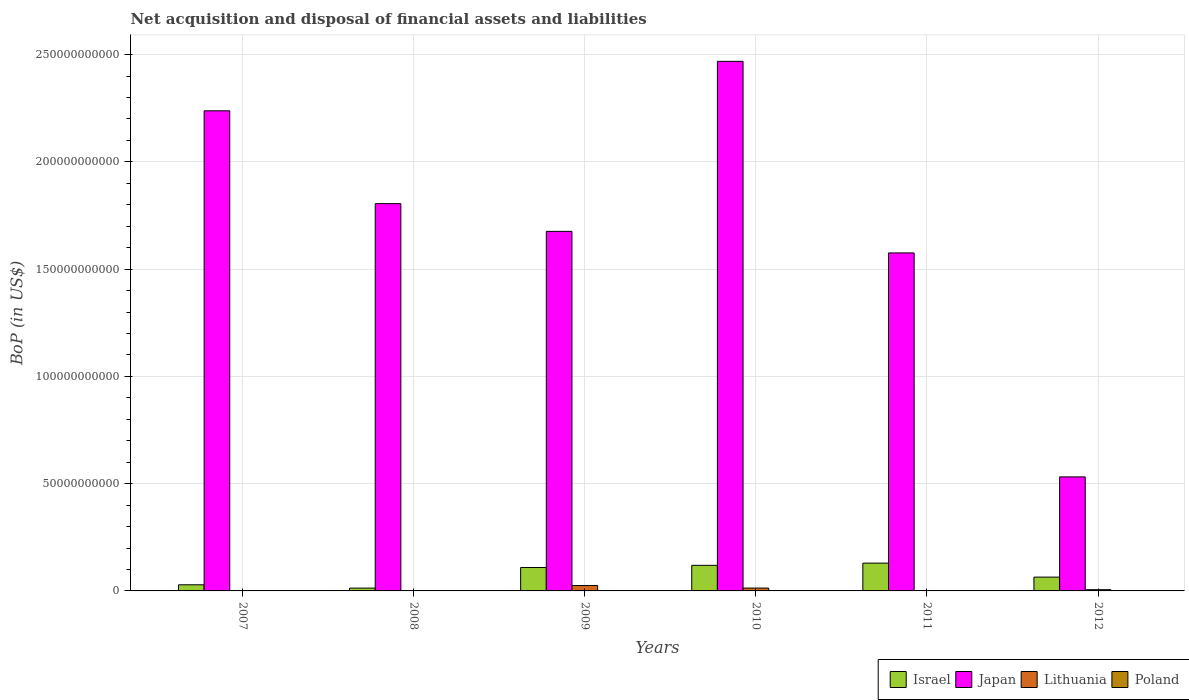How many bars are there on the 2nd tick from the left?
Offer a terse response. 2. How many bars are there on the 6th tick from the right?
Offer a very short reply. 2. What is the Balance of Payments in Japan in 2008?
Give a very brief answer. 1.81e+11. Across all years, what is the maximum Balance of Payments in Japan?
Make the answer very short. 2.47e+11. Across all years, what is the minimum Balance of Payments in Japan?
Make the answer very short. 5.32e+1. What is the total Balance of Payments in Israel in the graph?
Make the answer very short. 4.64e+1. What is the difference between the Balance of Payments in Israel in 2007 and that in 2011?
Your answer should be compact. -1.01e+1. What is the difference between the Balance of Payments in Japan in 2007 and the Balance of Payments in Poland in 2012?
Give a very brief answer. 2.24e+11. What is the average Balance of Payments in Israel per year?
Provide a succinct answer. 7.74e+09. In the year 2008, what is the difference between the Balance of Payments in Japan and Balance of Payments in Israel?
Your answer should be very brief. 1.79e+11. What is the ratio of the Balance of Payments in Israel in 2010 to that in 2012?
Provide a succinct answer. 1.85. What is the difference between the highest and the second highest Balance of Payments in Lithuania?
Your response must be concise. 1.18e+09. What is the difference between the highest and the lowest Balance of Payments in Lithuania?
Make the answer very short. 2.51e+09. In how many years, is the Balance of Payments in Japan greater than the average Balance of Payments in Japan taken over all years?
Give a very brief answer. 3. Is the sum of the Balance of Payments in Israel in 2008 and 2010 greater than the maximum Balance of Payments in Poland across all years?
Keep it short and to the point. Yes. Is it the case that in every year, the sum of the Balance of Payments in Japan and Balance of Payments in Poland is greater than the Balance of Payments in Israel?
Keep it short and to the point. Yes. How many bars are there?
Offer a terse response. 15. What is the difference between two consecutive major ticks on the Y-axis?
Your answer should be compact. 5.00e+1. Are the values on the major ticks of Y-axis written in scientific E-notation?
Offer a terse response. No. Where does the legend appear in the graph?
Your answer should be very brief. Bottom right. How are the legend labels stacked?
Keep it short and to the point. Horizontal. What is the title of the graph?
Provide a short and direct response. Net acquisition and disposal of financial assets and liabilities. What is the label or title of the Y-axis?
Make the answer very short. BoP (in US$). What is the BoP (in US$) of Israel in 2007?
Make the answer very short. 2.86e+09. What is the BoP (in US$) in Japan in 2007?
Provide a short and direct response. 2.24e+11. What is the BoP (in US$) in Lithuania in 2007?
Your response must be concise. 0. What is the BoP (in US$) in Israel in 2008?
Ensure brevity in your answer.  1.32e+09. What is the BoP (in US$) of Japan in 2008?
Keep it short and to the point. 1.81e+11. What is the BoP (in US$) in Lithuania in 2008?
Give a very brief answer. 0. What is the BoP (in US$) of Israel in 2009?
Offer a terse response. 1.09e+1. What is the BoP (in US$) in Japan in 2009?
Provide a short and direct response. 1.68e+11. What is the BoP (in US$) in Lithuania in 2009?
Give a very brief answer. 2.51e+09. What is the BoP (in US$) of Israel in 2010?
Provide a succinct answer. 1.19e+1. What is the BoP (in US$) of Japan in 2010?
Make the answer very short. 2.47e+11. What is the BoP (in US$) of Lithuania in 2010?
Provide a short and direct response. 1.34e+09. What is the BoP (in US$) in Poland in 2010?
Provide a succinct answer. 0. What is the BoP (in US$) in Israel in 2011?
Your answer should be very brief. 1.30e+1. What is the BoP (in US$) of Japan in 2011?
Make the answer very short. 1.58e+11. What is the BoP (in US$) of Israel in 2012?
Offer a terse response. 6.43e+09. What is the BoP (in US$) of Japan in 2012?
Provide a succinct answer. 5.32e+1. What is the BoP (in US$) of Lithuania in 2012?
Your response must be concise. 5.72e+08. Across all years, what is the maximum BoP (in US$) in Israel?
Keep it short and to the point. 1.30e+1. Across all years, what is the maximum BoP (in US$) in Japan?
Offer a terse response. 2.47e+11. Across all years, what is the maximum BoP (in US$) in Lithuania?
Provide a short and direct response. 2.51e+09. Across all years, what is the minimum BoP (in US$) of Israel?
Keep it short and to the point. 1.32e+09. Across all years, what is the minimum BoP (in US$) in Japan?
Give a very brief answer. 5.32e+1. What is the total BoP (in US$) in Israel in the graph?
Keep it short and to the point. 4.64e+1. What is the total BoP (in US$) of Japan in the graph?
Make the answer very short. 1.03e+12. What is the total BoP (in US$) in Lithuania in the graph?
Make the answer very short. 4.42e+09. What is the total BoP (in US$) of Poland in the graph?
Ensure brevity in your answer.  0. What is the difference between the BoP (in US$) of Israel in 2007 and that in 2008?
Provide a short and direct response. 1.54e+09. What is the difference between the BoP (in US$) in Japan in 2007 and that in 2008?
Keep it short and to the point. 4.33e+1. What is the difference between the BoP (in US$) in Israel in 2007 and that in 2009?
Provide a succinct answer. -8.06e+09. What is the difference between the BoP (in US$) in Japan in 2007 and that in 2009?
Your response must be concise. 5.62e+1. What is the difference between the BoP (in US$) of Israel in 2007 and that in 2010?
Your response must be concise. -9.07e+09. What is the difference between the BoP (in US$) of Japan in 2007 and that in 2010?
Give a very brief answer. -2.31e+1. What is the difference between the BoP (in US$) in Israel in 2007 and that in 2011?
Keep it short and to the point. -1.01e+1. What is the difference between the BoP (in US$) in Japan in 2007 and that in 2011?
Ensure brevity in your answer.  6.63e+1. What is the difference between the BoP (in US$) in Israel in 2007 and that in 2012?
Offer a very short reply. -3.57e+09. What is the difference between the BoP (in US$) in Japan in 2007 and that in 2012?
Offer a terse response. 1.71e+11. What is the difference between the BoP (in US$) in Israel in 2008 and that in 2009?
Your answer should be very brief. -9.60e+09. What is the difference between the BoP (in US$) in Japan in 2008 and that in 2009?
Ensure brevity in your answer.  1.29e+1. What is the difference between the BoP (in US$) in Israel in 2008 and that in 2010?
Your answer should be very brief. -1.06e+1. What is the difference between the BoP (in US$) in Japan in 2008 and that in 2010?
Give a very brief answer. -6.63e+1. What is the difference between the BoP (in US$) in Israel in 2008 and that in 2011?
Give a very brief answer. -1.16e+1. What is the difference between the BoP (in US$) of Japan in 2008 and that in 2011?
Provide a succinct answer. 2.30e+1. What is the difference between the BoP (in US$) of Israel in 2008 and that in 2012?
Your response must be concise. -5.12e+09. What is the difference between the BoP (in US$) in Japan in 2008 and that in 2012?
Offer a very short reply. 1.27e+11. What is the difference between the BoP (in US$) of Israel in 2009 and that in 2010?
Your answer should be compact. -1.01e+09. What is the difference between the BoP (in US$) in Japan in 2009 and that in 2010?
Keep it short and to the point. -7.93e+1. What is the difference between the BoP (in US$) of Lithuania in 2009 and that in 2010?
Offer a very short reply. 1.18e+09. What is the difference between the BoP (in US$) of Israel in 2009 and that in 2011?
Your answer should be very brief. -2.04e+09. What is the difference between the BoP (in US$) in Japan in 2009 and that in 2011?
Your response must be concise. 1.01e+1. What is the difference between the BoP (in US$) in Israel in 2009 and that in 2012?
Provide a succinct answer. 4.48e+09. What is the difference between the BoP (in US$) of Japan in 2009 and that in 2012?
Your answer should be very brief. 1.14e+11. What is the difference between the BoP (in US$) in Lithuania in 2009 and that in 2012?
Your response must be concise. 1.94e+09. What is the difference between the BoP (in US$) in Israel in 2010 and that in 2011?
Ensure brevity in your answer.  -1.04e+09. What is the difference between the BoP (in US$) of Japan in 2010 and that in 2011?
Keep it short and to the point. 8.93e+1. What is the difference between the BoP (in US$) in Israel in 2010 and that in 2012?
Provide a succinct answer. 5.49e+09. What is the difference between the BoP (in US$) in Japan in 2010 and that in 2012?
Your answer should be compact. 1.94e+11. What is the difference between the BoP (in US$) in Lithuania in 2010 and that in 2012?
Your response must be concise. 7.67e+08. What is the difference between the BoP (in US$) in Israel in 2011 and that in 2012?
Your response must be concise. 6.53e+09. What is the difference between the BoP (in US$) in Japan in 2011 and that in 2012?
Your response must be concise. 1.04e+11. What is the difference between the BoP (in US$) of Israel in 2007 and the BoP (in US$) of Japan in 2008?
Your response must be concise. -1.78e+11. What is the difference between the BoP (in US$) in Israel in 2007 and the BoP (in US$) in Japan in 2009?
Give a very brief answer. -1.65e+11. What is the difference between the BoP (in US$) in Israel in 2007 and the BoP (in US$) in Lithuania in 2009?
Keep it short and to the point. 3.48e+08. What is the difference between the BoP (in US$) in Japan in 2007 and the BoP (in US$) in Lithuania in 2009?
Your response must be concise. 2.21e+11. What is the difference between the BoP (in US$) in Israel in 2007 and the BoP (in US$) in Japan in 2010?
Give a very brief answer. -2.44e+11. What is the difference between the BoP (in US$) in Israel in 2007 and the BoP (in US$) in Lithuania in 2010?
Your answer should be very brief. 1.52e+09. What is the difference between the BoP (in US$) in Japan in 2007 and the BoP (in US$) in Lithuania in 2010?
Your answer should be very brief. 2.22e+11. What is the difference between the BoP (in US$) of Israel in 2007 and the BoP (in US$) of Japan in 2011?
Your answer should be compact. -1.55e+11. What is the difference between the BoP (in US$) in Israel in 2007 and the BoP (in US$) in Japan in 2012?
Ensure brevity in your answer.  -5.03e+1. What is the difference between the BoP (in US$) of Israel in 2007 and the BoP (in US$) of Lithuania in 2012?
Offer a very short reply. 2.29e+09. What is the difference between the BoP (in US$) in Japan in 2007 and the BoP (in US$) in Lithuania in 2012?
Give a very brief answer. 2.23e+11. What is the difference between the BoP (in US$) in Israel in 2008 and the BoP (in US$) in Japan in 2009?
Make the answer very short. -1.66e+11. What is the difference between the BoP (in US$) in Israel in 2008 and the BoP (in US$) in Lithuania in 2009?
Make the answer very short. -1.20e+09. What is the difference between the BoP (in US$) of Japan in 2008 and the BoP (in US$) of Lithuania in 2009?
Give a very brief answer. 1.78e+11. What is the difference between the BoP (in US$) of Israel in 2008 and the BoP (in US$) of Japan in 2010?
Make the answer very short. -2.46e+11. What is the difference between the BoP (in US$) in Israel in 2008 and the BoP (in US$) in Lithuania in 2010?
Offer a very short reply. -2.12e+07. What is the difference between the BoP (in US$) in Japan in 2008 and the BoP (in US$) in Lithuania in 2010?
Your response must be concise. 1.79e+11. What is the difference between the BoP (in US$) of Israel in 2008 and the BoP (in US$) of Japan in 2011?
Ensure brevity in your answer.  -1.56e+11. What is the difference between the BoP (in US$) of Israel in 2008 and the BoP (in US$) of Japan in 2012?
Ensure brevity in your answer.  -5.18e+1. What is the difference between the BoP (in US$) in Israel in 2008 and the BoP (in US$) in Lithuania in 2012?
Offer a terse response. 7.46e+08. What is the difference between the BoP (in US$) of Japan in 2008 and the BoP (in US$) of Lithuania in 2012?
Keep it short and to the point. 1.80e+11. What is the difference between the BoP (in US$) of Israel in 2009 and the BoP (in US$) of Japan in 2010?
Provide a short and direct response. -2.36e+11. What is the difference between the BoP (in US$) of Israel in 2009 and the BoP (in US$) of Lithuania in 2010?
Your answer should be compact. 9.58e+09. What is the difference between the BoP (in US$) in Japan in 2009 and the BoP (in US$) in Lithuania in 2010?
Give a very brief answer. 1.66e+11. What is the difference between the BoP (in US$) in Israel in 2009 and the BoP (in US$) in Japan in 2011?
Your answer should be very brief. -1.47e+11. What is the difference between the BoP (in US$) in Israel in 2009 and the BoP (in US$) in Japan in 2012?
Your answer should be very brief. -4.22e+1. What is the difference between the BoP (in US$) of Israel in 2009 and the BoP (in US$) of Lithuania in 2012?
Give a very brief answer. 1.03e+1. What is the difference between the BoP (in US$) in Japan in 2009 and the BoP (in US$) in Lithuania in 2012?
Keep it short and to the point. 1.67e+11. What is the difference between the BoP (in US$) of Israel in 2010 and the BoP (in US$) of Japan in 2011?
Give a very brief answer. -1.46e+11. What is the difference between the BoP (in US$) in Israel in 2010 and the BoP (in US$) in Japan in 2012?
Ensure brevity in your answer.  -4.12e+1. What is the difference between the BoP (in US$) of Israel in 2010 and the BoP (in US$) of Lithuania in 2012?
Provide a short and direct response. 1.14e+1. What is the difference between the BoP (in US$) of Japan in 2010 and the BoP (in US$) of Lithuania in 2012?
Your response must be concise. 2.46e+11. What is the difference between the BoP (in US$) of Israel in 2011 and the BoP (in US$) of Japan in 2012?
Your response must be concise. -4.02e+1. What is the difference between the BoP (in US$) in Israel in 2011 and the BoP (in US$) in Lithuania in 2012?
Keep it short and to the point. 1.24e+1. What is the difference between the BoP (in US$) of Japan in 2011 and the BoP (in US$) of Lithuania in 2012?
Offer a very short reply. 1.57e+11. What is the average BoP (in US$) of Israel per year?
Keep it short and to the point. 7.74e+09. What is the average BoP (in US$) in Japan per year?
Your response must be concise. 1.72e+11. What is the average BoP (in US$) in Lithuania per year?
Give a very brief answer. 7.37e+08. What is the average BoP (in US$) of Poland per year?
Ensure brevity in your answer.  0. In the year 2007, what is the difference between the BoP (in US$) of Israel and BoP (in US$) of Japan?
Your answer should be very brief. -2.21e+11. In the year 2008, what is the difference between the BoP (in US$) in Israel and BoP (in US$) in Japan?
Keep it short and to the point. -1.79e+11. In the year 2009, what is the difference between the BoP (in US$) in Israel and BoP (in US$) in Japan?
Ensure brevity in your answer.  -1.57e+11. In the year 2009, what is the difference between the BoP (in US$) of Israel and BoP (in US$) of Lithuania?
Your response must be concise. 8.40e+09. In the year 2009, what is the difference between the BoP (in US$) in Japan and BoP (in US$) in Lithuania?
Give a very brief answer. 1.65e+11. In the year 2010, what is the difference between the BoP (in US$) in Israel and BoP (in US$) in Japan?
Your answer should be very brief. -2.35e+11. In the year 2010, what is the difference between the BoP (in US$) of Israel and BoP (in US$) of Lithuania?
Your response must be concise. 1.06e+1. In the year 2010, what is the difference between the BoP (in US$) of Japan and BoP (in US$) of Lithuania?
Your response must be concise. 2.46e+11. In the year 2011, what is the difference between the BoP (in US$) in Israel and BoP (in US$) in Japan?
Ensure brevity in your answer.  -1.45e+11. In the year 2012, what is the difference between the BoP (in US$) of Israel and BoP (in US$) of Japan?
Offer a very short reply. -4.67e+1. In the year 2012, what is the difference between the BoP (in US$) in Israel and BoP (in US$) in Lithuania?
Keep it short and to the point. 5.86e+09. In the year 2012, what is the difference between the BoP (in US$) in Japan and BoP (in US$) in Lithuania?
Provide a short and direct response. 5.26e+1. What is the ratio of the BoP (in US$) of Israel in 2007 to that in 2008?
Offer a very short reply. 2.17. What is the ratio of the BoP (in US$) in Japan in 2007 to that in 2008?
Offer a very short reply. 1.24. What is the ratio of the BoP (in US$) in Israel in 2007 to that in 2009?
Give a very brief answer. 0.26. What is the ratio of the BoP (in US$) of Japan in 2007 to that in 2009?
Your answer should be very brief. 1.34. What is the ratio of the BoP (in US$) in Israel in 2007 to that in 2010?
Provide a short and direct response. 0.24. What is the ratio of the BoP (in US$) in Japan in 2007 to that in 2010?
Ensure brevity in your answer.  0.91. What is the ratio of the BoP (in US$) of Israel in 2007 to that in 2011?
Keep it short and to the point. 0.22. What is the ratio of the BoP (in US$) of Japan in 2007 to that in 2011?
Provide a short and direct response. 1.42. What is the ratio of the BoP (in US$) of Israel in 2007 to that in 2012?
Give a very brief answer. 0.44. What is the ratio of the BoP (in US$) of Japan in 2007 to that in 2012?
Provide a succinct answer. 4.21. What is the ratio of the BoP (in US$) of Israel in 2008 to that in 2009?
Offer a terse response. 0.12. What is the ratio of the BoP (in US$) of Japan in 2008 to that in 2009?
Make the answer very short. 1.08. What is the ratio of the BoP (in US$) of Israel in 2008 to that in 2010?
Provide a succinct answer. 0.11. What is the ratio of the BoP (in US$) in Japan in 2008 to that in 2010?
Your response must be concise. 0.73. What is the ratio of the BoP (in US$) in Israel in 2008 to that in 2011?
Your answer should be compact. 0.1. What is the ratio of the BoP (in US$) in Japan in 2008 to that in 2011?
Offer a very short reply. 1.15. What is the ratio of the BoP (in US$) in Israel in 2008 to that in 2012?
Keep it short and to the point. 0.2. What is the ratio of the BoP (in US$) in Japan in 2008 to that in 2012?
Your answer should be very brief. 3.4. What is the ratio of the BoP (in US$) of Israel in 2009 to that in 2010?
Your response must be concise. 0.92. What is the ratio of the BoP (in US$) of Japan in 2009 to that in 2010?
Offer a very short reply. 0.68. What is the ratio of the BoP (in US$) in Lithuania in 2009 to that in 2010?
Your answer should be very brief. 1.88. What is the ratio of the BoP (in US$) in Israel in 2009 to that in 2011?
Your answer should be very brief. 0.84. What is the ratio of the BoP (in US$) of Japan in 2009 to that in 2011?
Make the answer very short. 1.06. What is the ratio of the BoP (in US$) in Israel in 2009 to that in 2012?
Your response must be concise. 1.7. What is the ratio of the BoP (in US$) in Japan in 2009 to that in 2012?
Your answer should be compact. 3.15. What is the ratio of the BoP (in US$) in Lithuania in 2009 to that in 2012?
Provide a short and direct response. 4.4. What is the ratio of the BoP (in US$) in Israel in 2010 to that in 2011?
Provide a succinct answer. 0.92. What is the ratio of the BoP (in US$) of Japan in 2010 to that in 2011?
Make the answer very short. 1.57. What is the ratio of the BoP (in US$) in Israel in 2010 to that in 2012?
Your answer should be very brief. 1.85. What is the ratio of the BoP (in US$) of Japan in 2010 to that in 2012?
Your response must be concise. 4.64. What is the ratio of the BoP (in US$) in Lithuania in 2010 to that in 2012?
Provide a succinct answer. 2.34. What is the ratio of the BoP (in US$) of Israel in 2011 to that in 2012?
Ensure brevity in your answer.  2.01. What is the ratio of the BoP (in US$) of Japan in 2011 to that in 2012?
Keep it short and to the point. 2.96. What is the difference between the highest and the second highest BoP (in US$) of Israel?
Offer a terse response. 1.04e+09. What is the difference between the highest and the second highest BoP (in US$) in Japan?
Your answer should be compact. 2.31e+1. What is the difference between the highest and the second highest BoP (in US$) in Lithuania?
Your response must be concise. 1.18e+09. What is the difference between the highest and the lowest BoP (in US$) of Israel?
Make the answer very short. 1.16e+1. What is the difference between the highest and the lowest BoP (in US$) of Japan?
Offer a terse response. 1.94e+11. What is the difference between the highest and the lowest BoP (in US$) in Lithuania?
Give a very brief answer. 2.51e+09. 